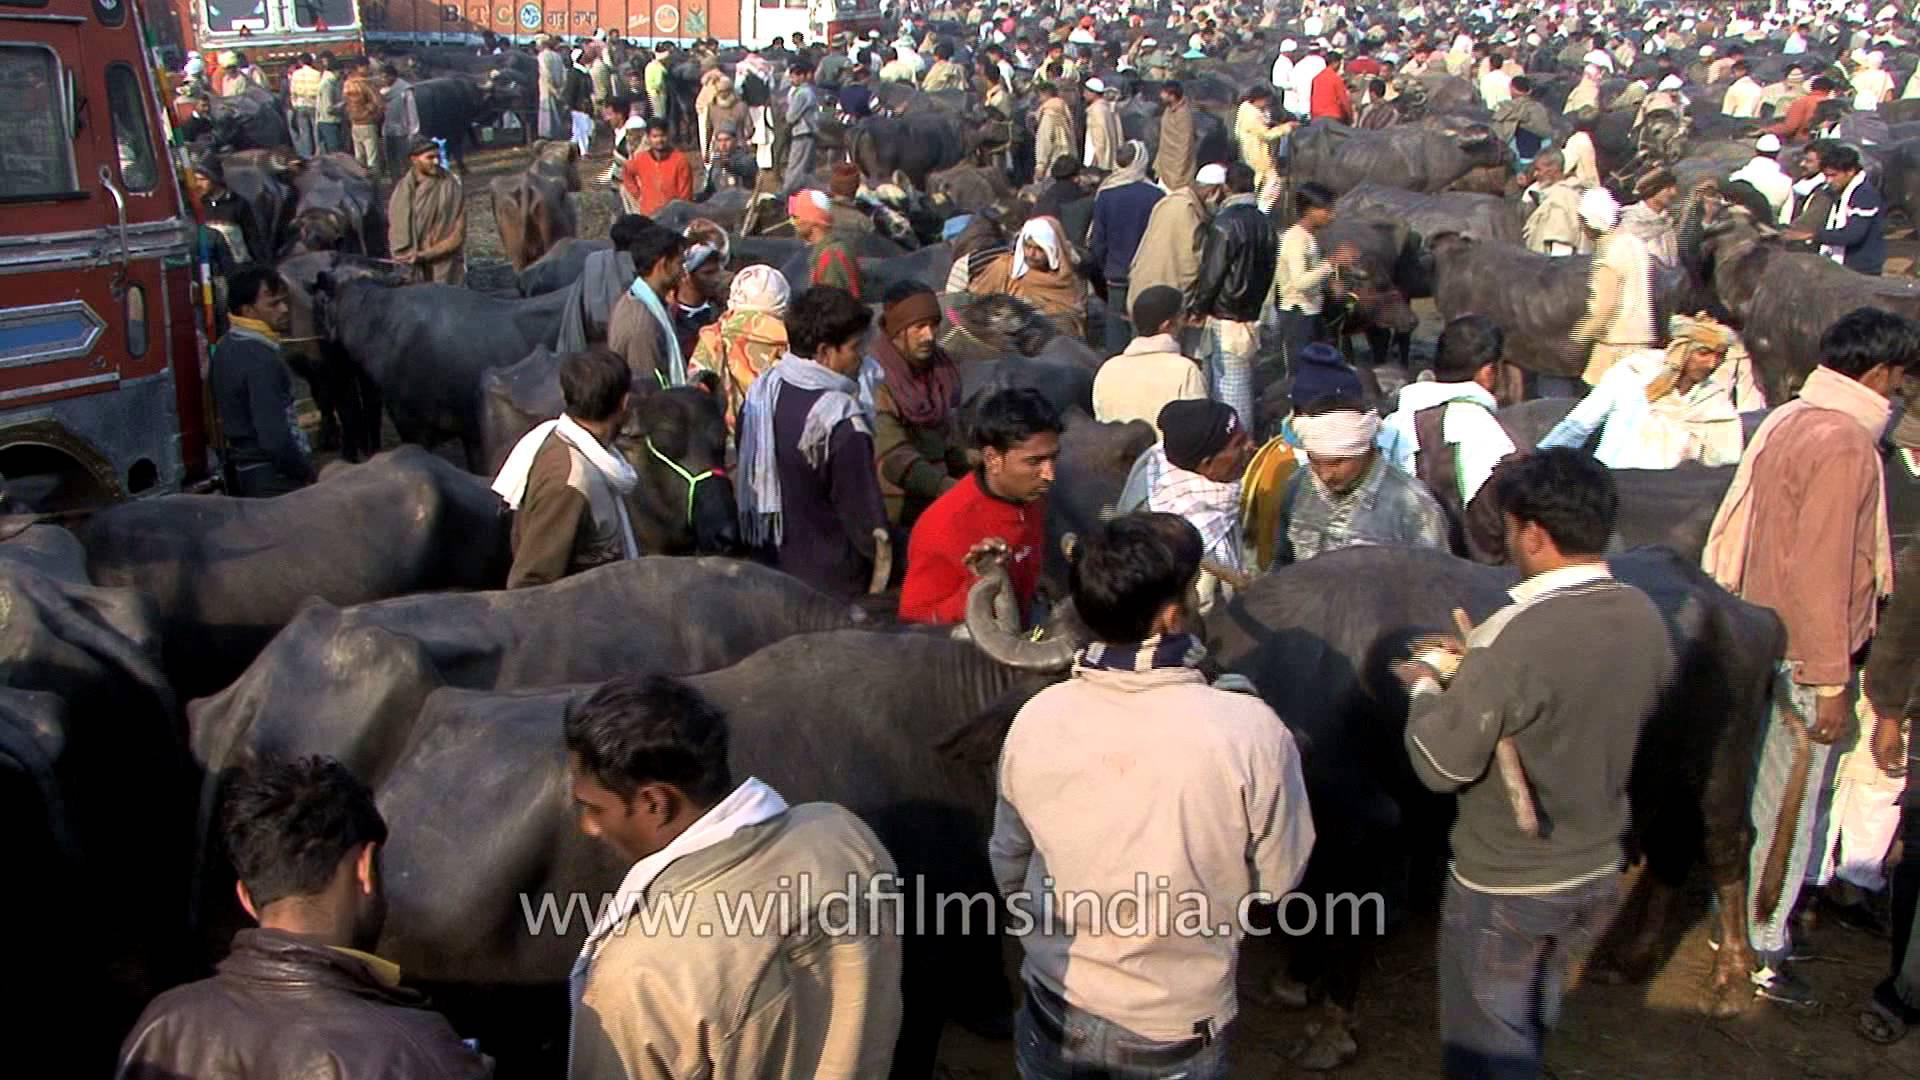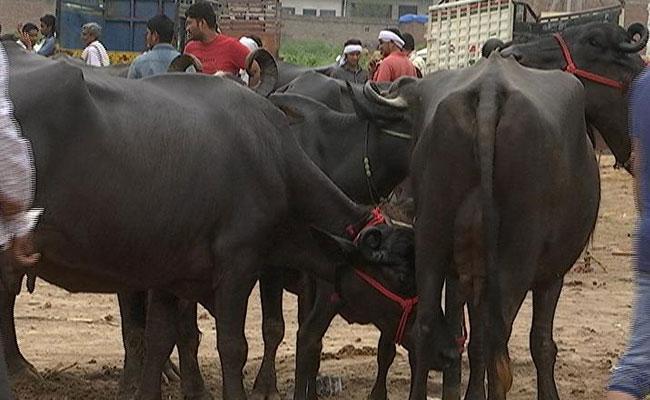The first image is the image on the left, the second image is the image on the right. For the images shown, is this caption "A crowd of people and cows gather together in a dirt surfaced area." true? Answer yes or no. Yes. The first image is the image on the left, the second image is the image on the right. For the images shown, is this caption "One image shows cattle standing facing forward on dirt ground, with columns holding up a roof in the background but no people present." true? Answer yes or no. No. 